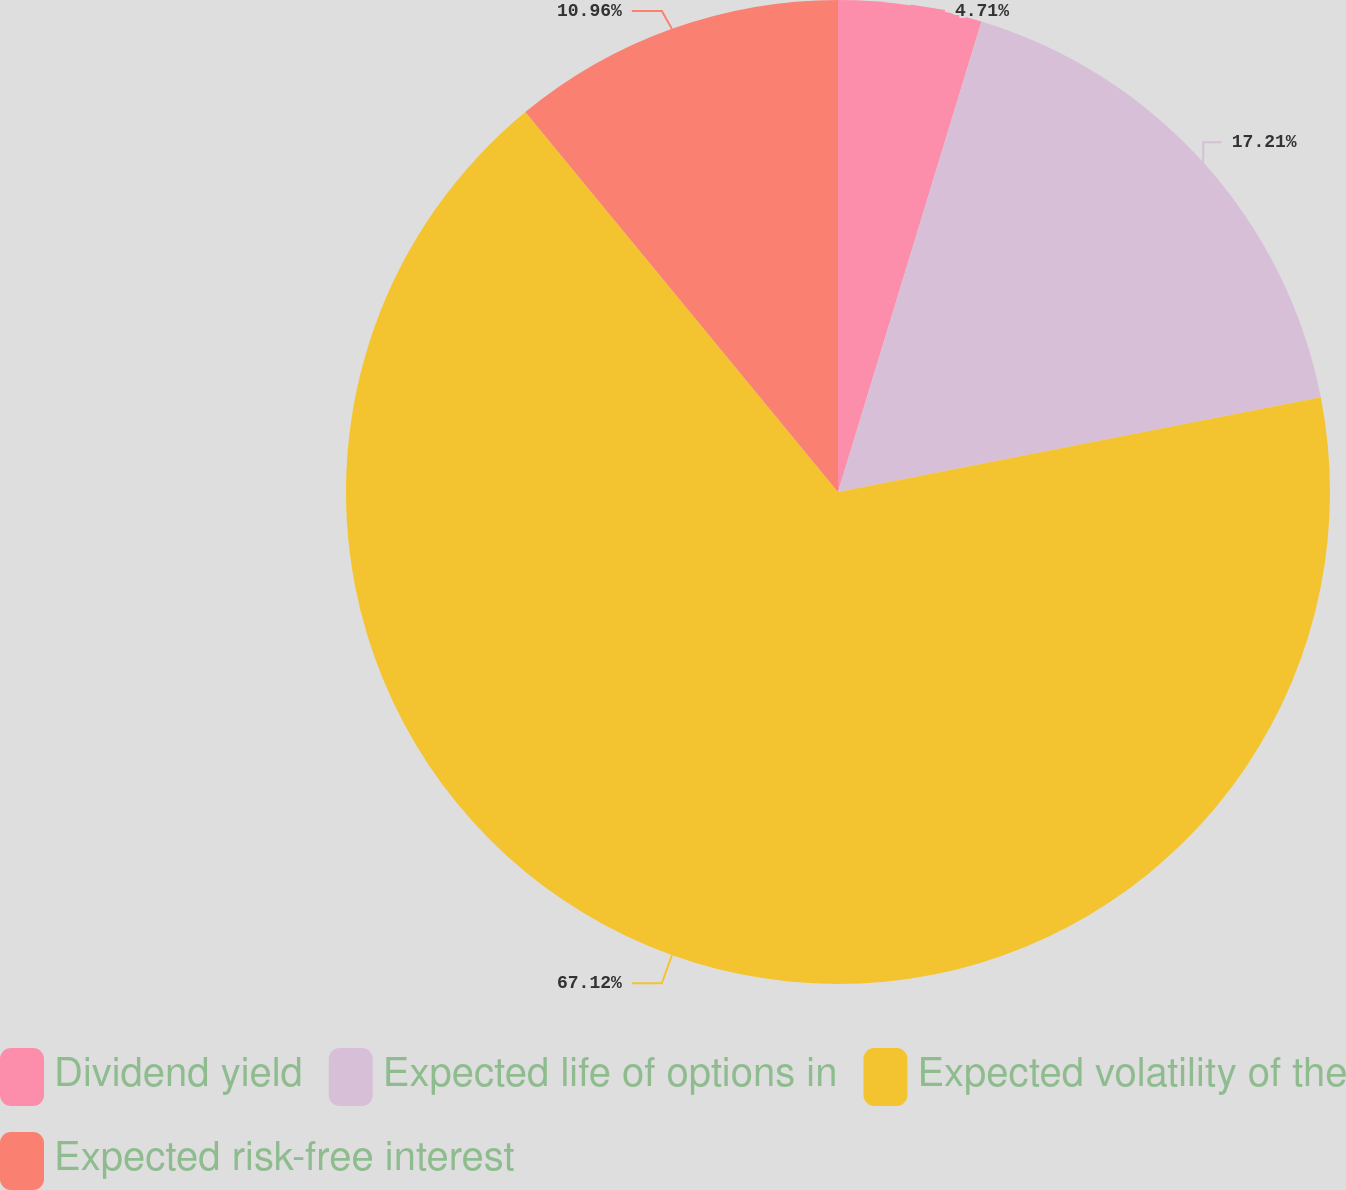<chart> <loc_0><loc_0><loc_500><loc_500><pie_chart><fcel>Dividend yield<fcel>Expected life of options in<fcel>Expected volatility of the<fcel>Expected risk-free interest<nl><fcel>4.71%<fcel>17.21%<fcel>67.13%<fcel>10.96%<nl></chart> 